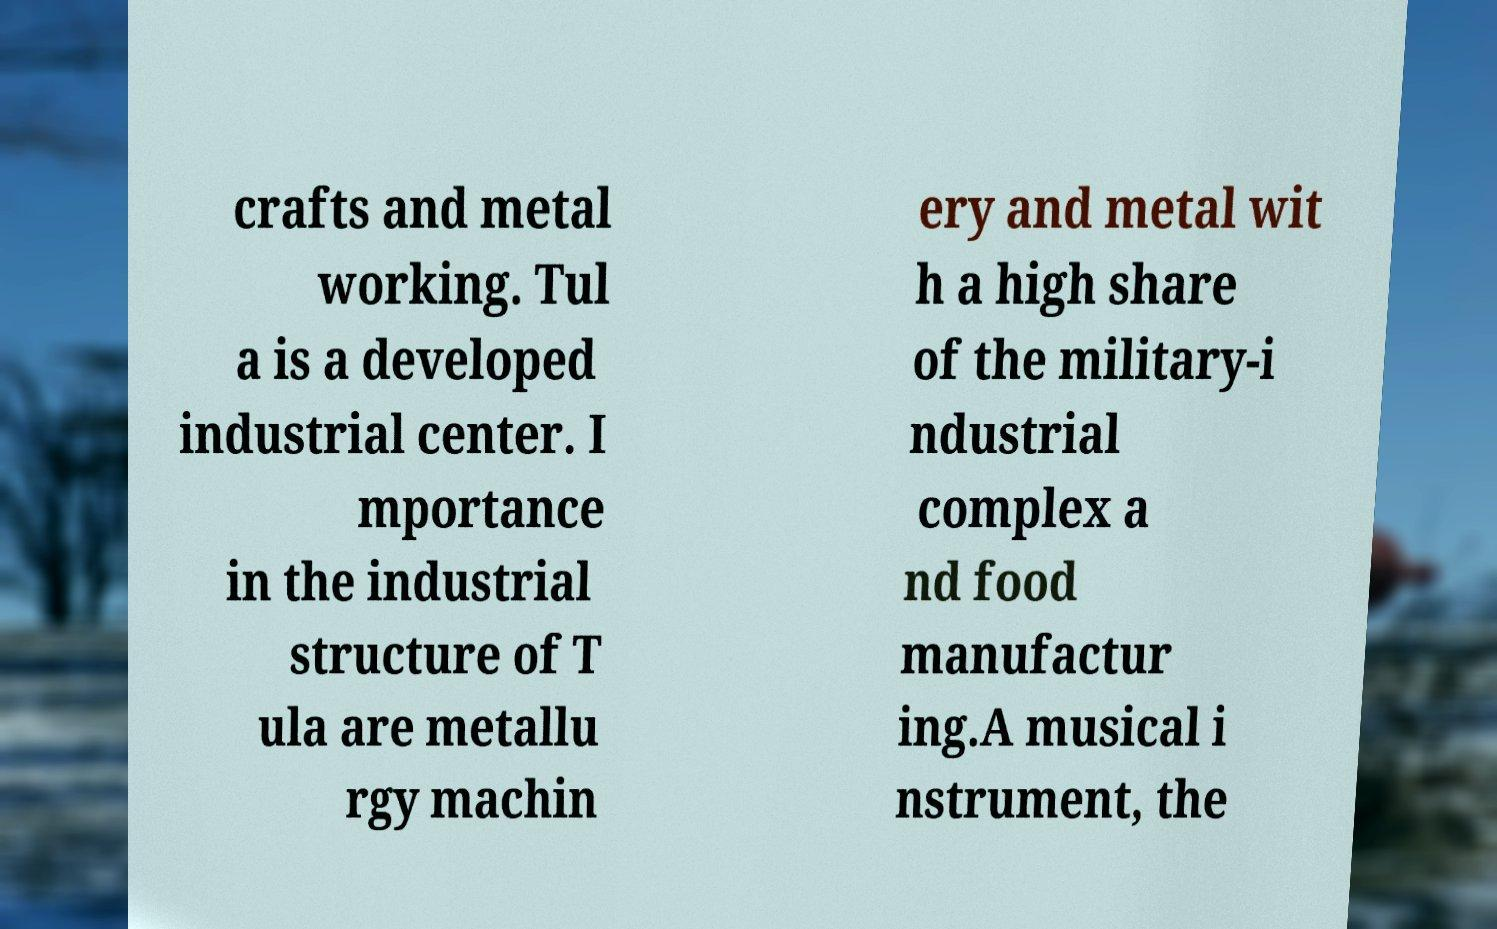There's text embedded in this image that I need extracted. Can you transcribe it verbatim? crafts and metal working. Tul a is a developed industrial center. I mportance in the industrial structure of T ula are metallu rgy machin ery and metal wit h a high share of the military-i ndustrial complex a nd food manufactur ing.A musical i nstrument, the 